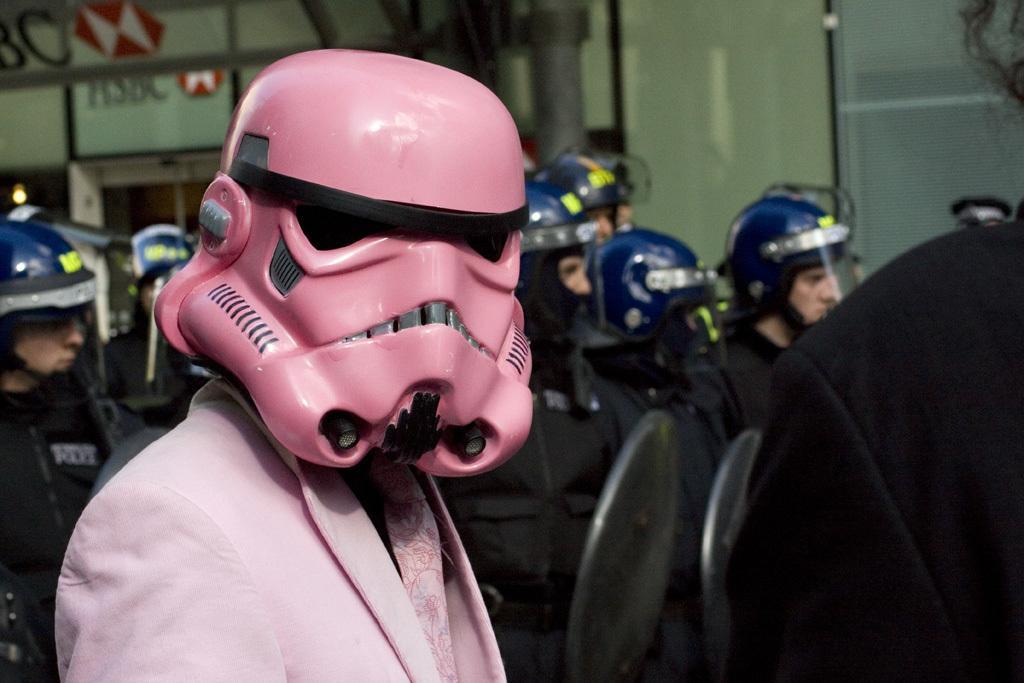How would you summarize this image in a sentence or two? In this image there is a person who is wearing the pink color suit is wearing the pink color mask. In the background there are few officers who are standing by wearing the jackets,helmets and holding the shields. On the left side top there is a building on which there is some script. 